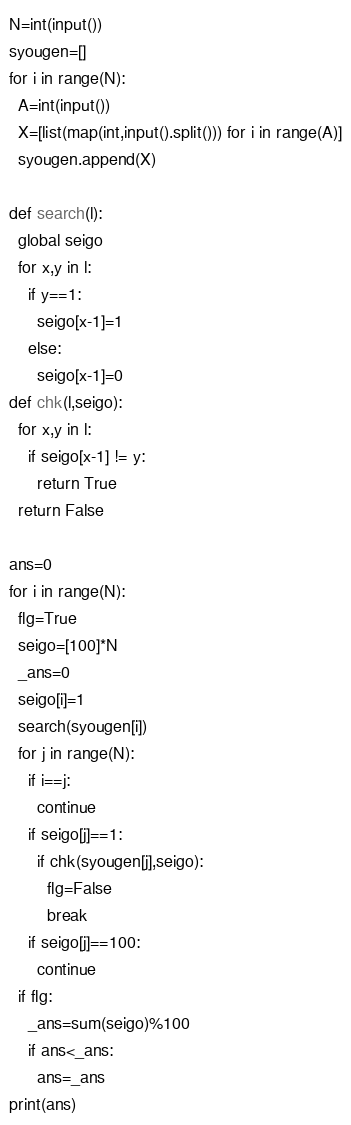Convert code to text. <code><loc_0><loc_0><loc_500><loc_500><_Python_>N=int(input())
syougen=[]
for i in range(N):
  A=int(input())
  X=[list(map(int,input().split())) for i in range(A)]
  syougen.append(X)

def search(l):
  global seigo
  for x,y in l:
    if y==1:
      seigo[x-1]=1
    else:
      seigo[x-1]=0
def chk(l,seigo):
  for x,y in l:
    if seigo[x-1] != y:
      return True
  return False

ans=0
for i in range(N):
  flg=True
  seigo=[100]*N
  _ans=0
  seigo[i]=1
  search(syougen[i])
  for j in range(N):
    if i==j:
      continue
    if seigo[j]==1:
      if chk(syougen[j],seigo):
        flg=False
        break
    if seigo[j]==100:
      continue
  if flg:
    _ans=sum(seigo)%100
    if ans<_ans:
      ans=_ans
print(ans)</code> 